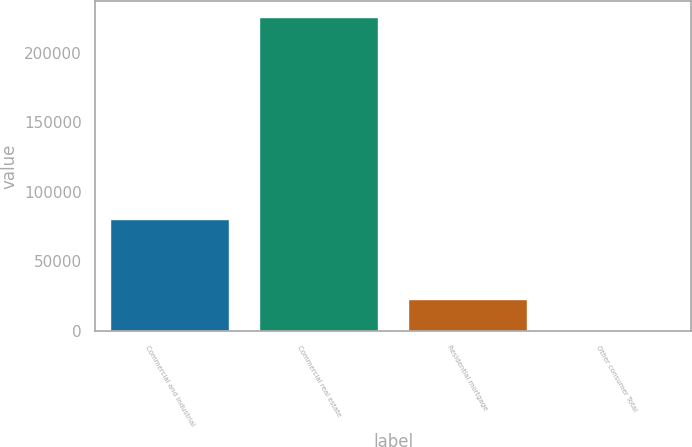Convert chart to OTSL. <chart><loc_0><loc_0><loc_500><loc_500><bar_chart><fcel>Commercial and industrial<fcel>Commercial real estate<fcel>Residential mortgage<fcel>Other consumer Total<nl><fcel>80294<fcel>226093<fcel>22829.8<fcel>245<nl></chart> 